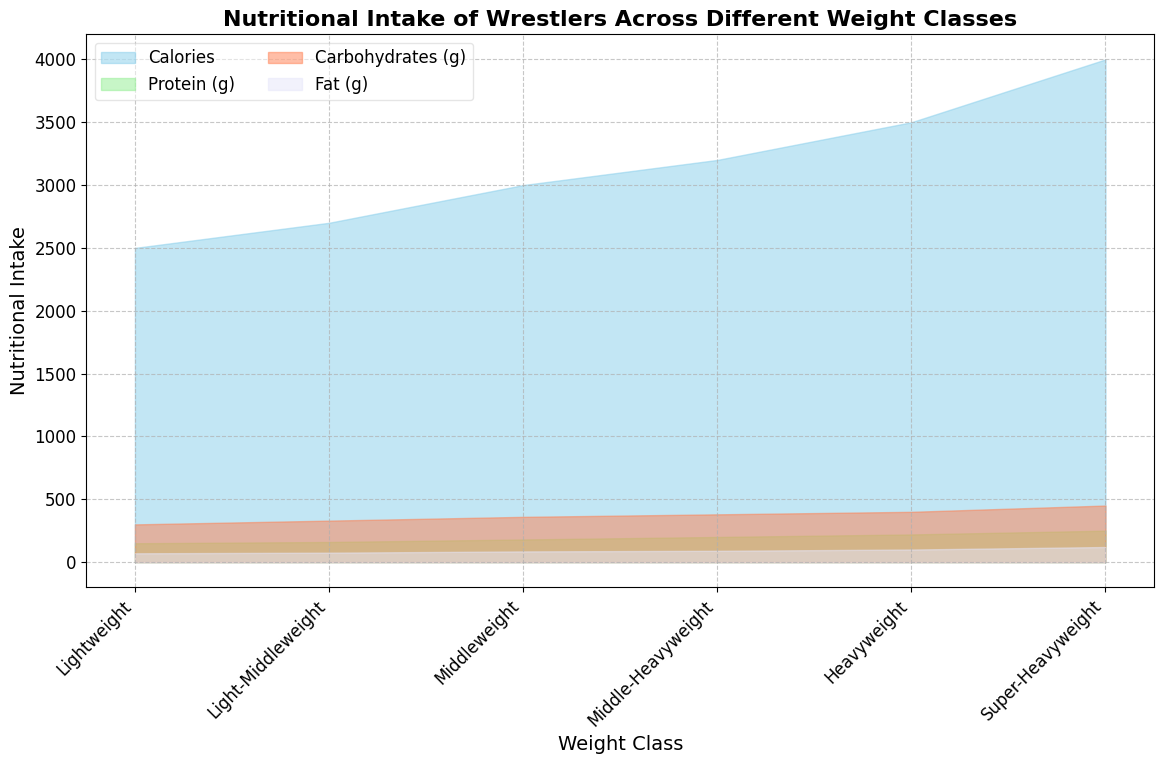What weight class requires the most caloric intake? The highest area segment for "Calories" is near the end of the x-axis corresponding to the "Super-Heavyweight" class.
Answer: Super-Heavyweight Which nutrient intake increases the least from Lightweight to Super-Heavyweight? Comparing the color-coded area segments for all nutrients, the "Fat (g)" segment, shown in lavender, experiences the smallest increase.
Answer: Fat (g) How does the protein intake for Middleweight compare visually to Heavyweight? The height of the green (Protein) area for Heavyweight is slightly higher than that for Middleweight, indicating more protein intake in Heavyweight.
Answer: Higher What is the visual pattern of calorie intake across all weight classes? The sky blue area representing "Calories" steadily increases as we move from left to right across the x-axis from Lightweight to Super-Heavyweight.
Answer: Steadily increases Which nutrient has the highest intake in the Lightweight class? The tallest area segment in the Lightweight class is sky blue, indicating that "Calories" have the highest intake.
Answer: Calories Comparing Light-Middleweight and Middleweight, which class shows a greater increase in carbohydrate intake relative to protein intake? Looking at the heights of orange (Carbohydrates) and green (Protein) areas, the increase in orange (relative to green) is more evident between Light-Middleweight and Middleweight.
Answer: Middleweight Calculate the total intake of nutrients (calories + protein + carbohydrates + fat) for the Middle-Heavyweight class. The nutrient values sum up as 3200 (Calories) + 200 (Protein) + 380 (Carbohydrates) + 90 (Fat), which equals 3870.
Answer: 3870 By how much does the fat intake increase from Lightweight to Middleweight? The difference in lavender area heights between Middleweight (85) and Lightweight (70) gives an increase of 85 - 70 = 15.
Answer: 15 Which nutrient shows the most significant percentage increase from Light-Middleweight to Super-Heavyweight? Calculate percentage increases: Calories (4000-2700)/2700 ≈ 48.1%, Protein (250-160)/160 ≈ 56.25%, Carbohydrates (450-330)/330 ≈ 36.36%, and Fat (120-75)/75 ≈ 60%. The highest percentage increase is for Fat.
Answer: Fat 